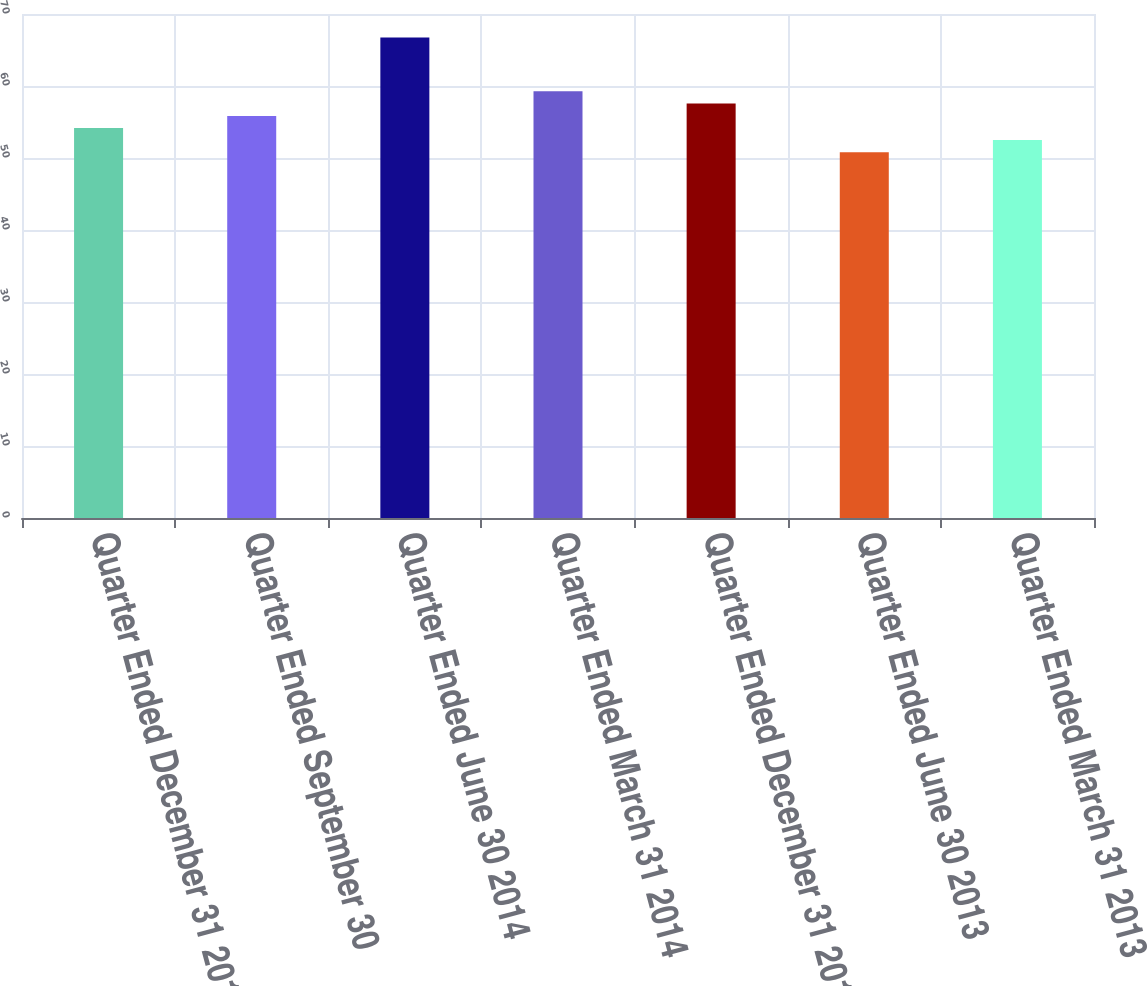Convert chart. <chart><loc_0><loc_0><loc_500><loc_500><bar_chart><fcel>Quarter Ended December 31 2014<fcel>Quarter Ended September 30<fcel>Quarter Ended June 30 2014<fcel>Quarter Ended March 31 2014<fcel>Quarter Ended December 31 2013<fcel>Quarter Ended June 30 2013<fcel>Quarter Ended March 31 2013<nl><fcel>54.17<fcel>55.85<fcel>66.75<fcel>59.26<fcel>57.58<fcel>50.81<fcel>52.49<nl></chart> 